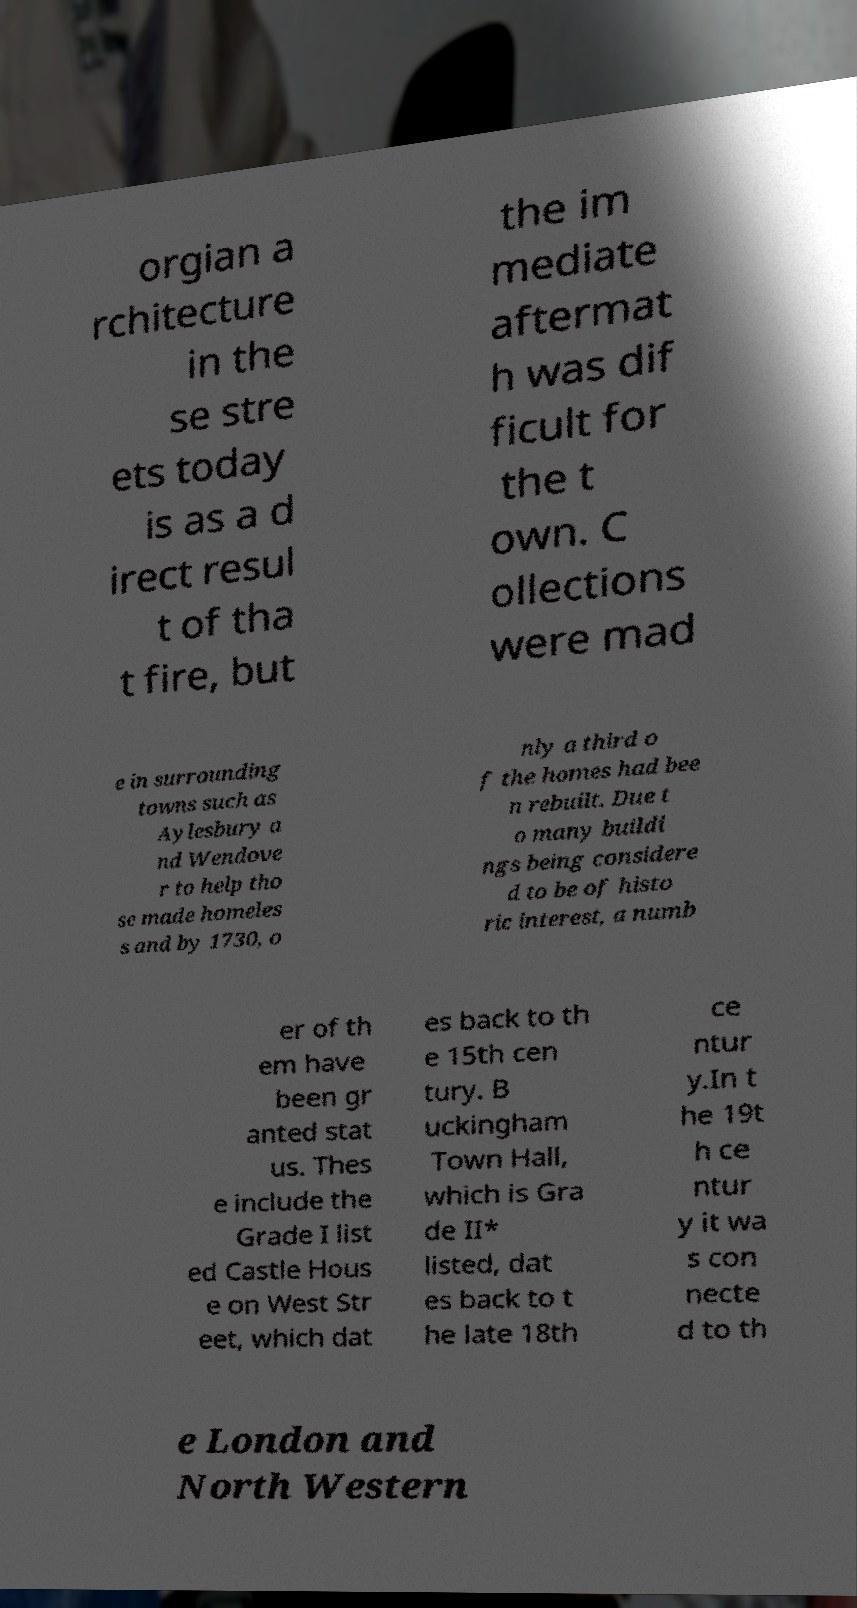There's text embedded in this image that I need extracted. Can you transcribe it verbatim? orgian a rchitecture in the se stre ets today is as a d irect resul t of tha t fire, but the im mediate aftermat h was dif ficult for the t own. C ollections were mad e in surrounding towns such as Aylesbury a nd Wendove r to help tho se made homeles s and by 1730, o nly a third o f the homes had bee n rebuilt. Due t o many buildi ngs being considere d to be of histo ric interest, a numb er of th em have been gr anted stat us. Thes e include the Grade I list ed Castle Hous e on West Str eet, which dat es back to th e 15th cen tury. B uckingham Town Hall, which is Gra de II* listed, dat es back to t he late 18th ce ntur y.In t he 19t h ce ntur y it wa s con necte d to th e London and North Western 